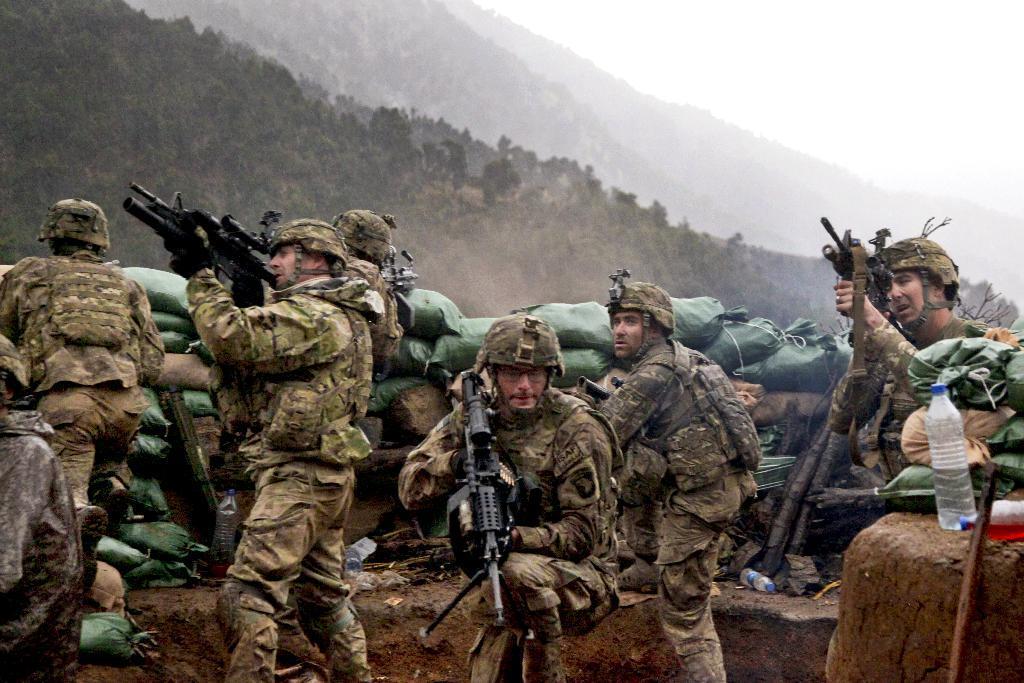Can you describe this image briefly? In this picture we can see a group of people holding guns with their hands, bottles, bags, trees, mountains and in the background we can see the sky. 